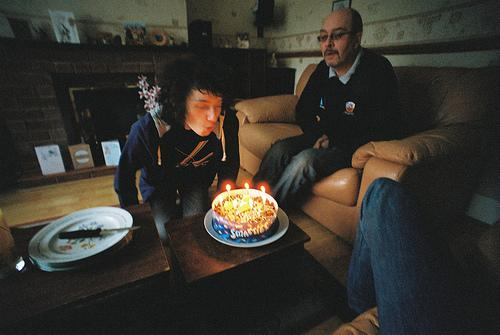Point out the main elements and actions taking place in the image. Key elements include a woman blowing out cake candles, a man wearing glasses on a couch, a knife resting on a plate, and an unlit red brick fireplace. Identify the theme of the image and elaborate on the elements. The image features a birthday celebration, including a woman blowing out candles on a cake, a man with glasses seated on a couch, a knife on a stack of plates, and a fireplace without fire. Write about the image using descriptive language. In a warm birthday gathering, a woman gently breathes upon lit candles adorning a cake, as a spectacled man lounges on a nearby couch, a fireplace lies unlit, and a knife accompanies a stack of plates. What is the central event occurring within the image? The central event is a woman blowing out candles on a birthday cake during a celebration. Relate the scene as if you were a witness describing the events. At the birthday party, I saw a woman blowing out candles on her cake, while a man wearing glasses observed from his seat on the couch, and a knife was placed on a stack of plates near an unlit fireplace. Explain the image in a single sentence. A birthday party scene with a woman blowing out candles on a cake, and a man wearing glasses seated on a couch near an unlit fireplace. Mention the actions of the people and the objects in the image. A woman is blowing out candles on a cake, a man in glasses sits on a couch, a knife rests on a plate, and a fireplace sits cold without flames. List the primary elements in the image. Birthday cake, woman blowing out candles, man with glasses on couch, knife on plate, unlit fireplace, stack of plates. Compose a brief summary of the scene depicted in the image. A birthday celebration showing a woman blowing out candles on a cake, a man sitting on a couch, a knife on a plate, and a fireplace without fire. Describe the scene incorporating the table, fireplace, and people. A cozy birthday scene with a woman blowing out candles on a cake set atop a brown wooden table, a man wearing glasses seated on a nearby couch, and a cold red brick fireplace. 